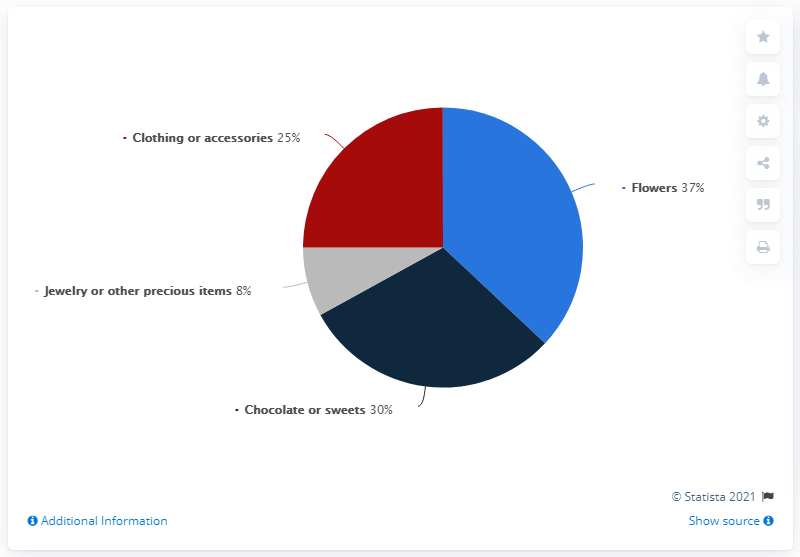Highlight a few significant elements in this photo. The color red typically signifies either clothing or accessories, but it can also have different meanings depending on the context in which it is used. The ratio of clothing or accessories to chocolate or sweet is 0.833333333... 